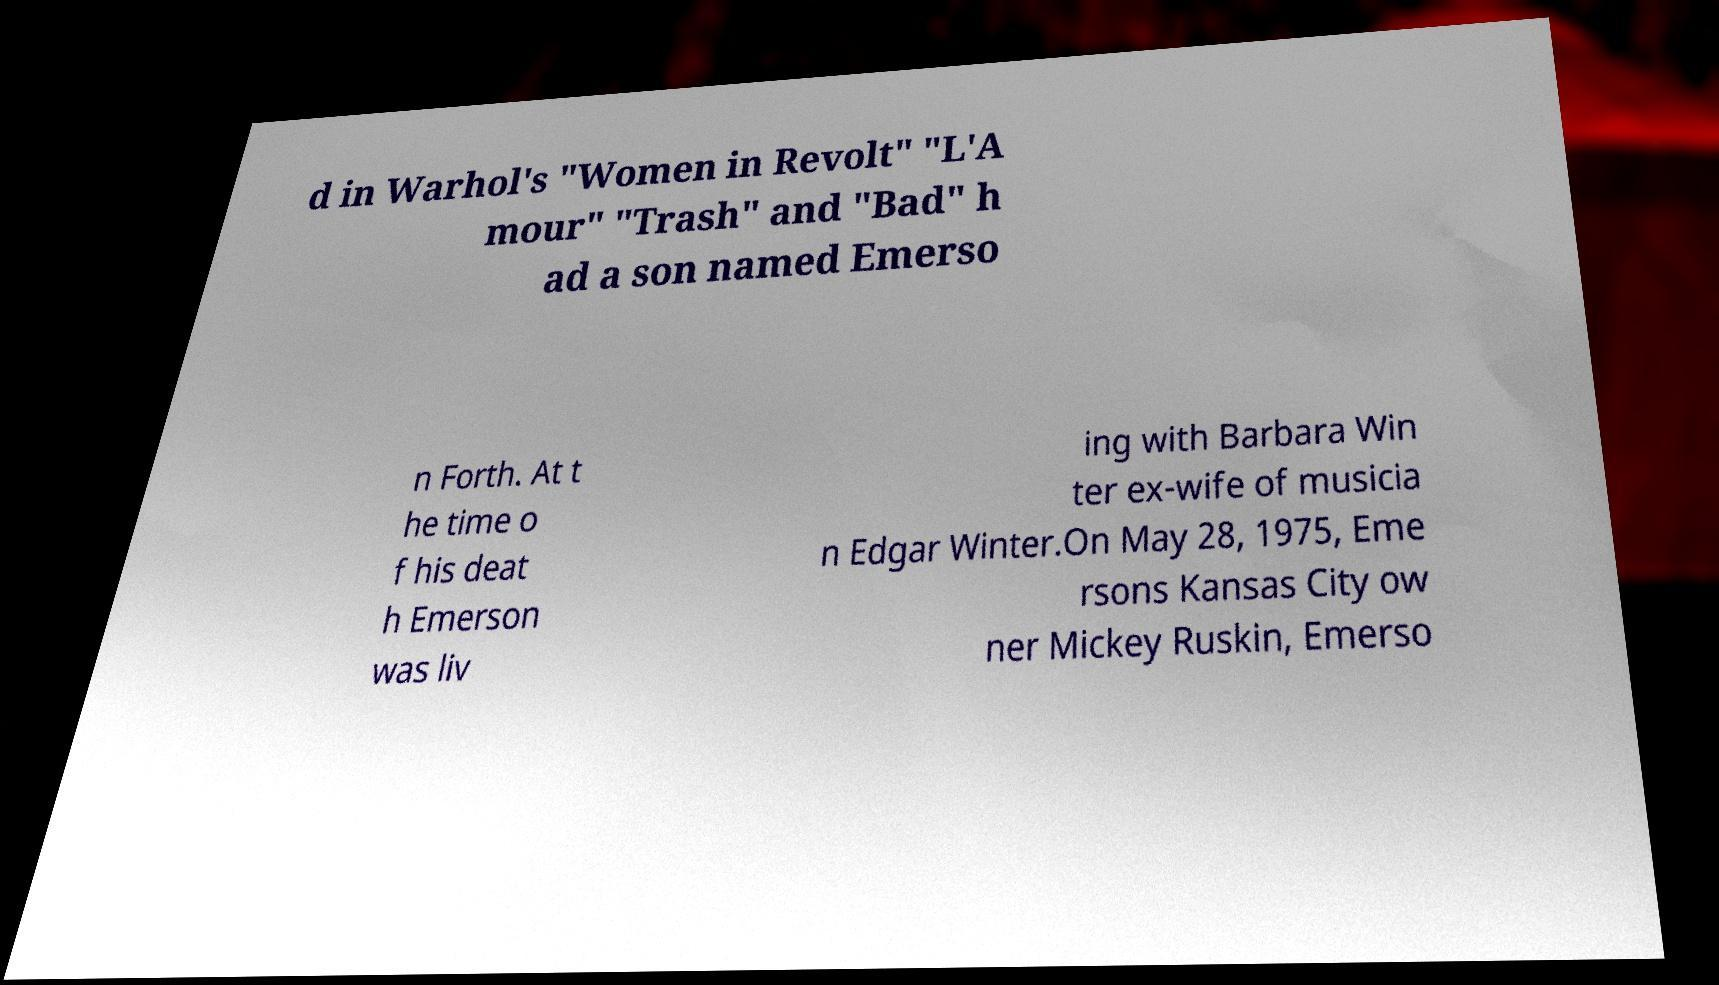Please identify and transcribe the text found in this image. d in Warhol's "Women in Revolt" "L'A mour" "Trash" and "Bad" h ad a son named Emerso n Forth. At t he time o f his deat h Emerson was liv ing with Barbara Win ter ex-wife of musicia n Edgar Winter.On May 28, 1975, Eme rsons Kansas City ow ner Mickey Ruskin, Emerso 